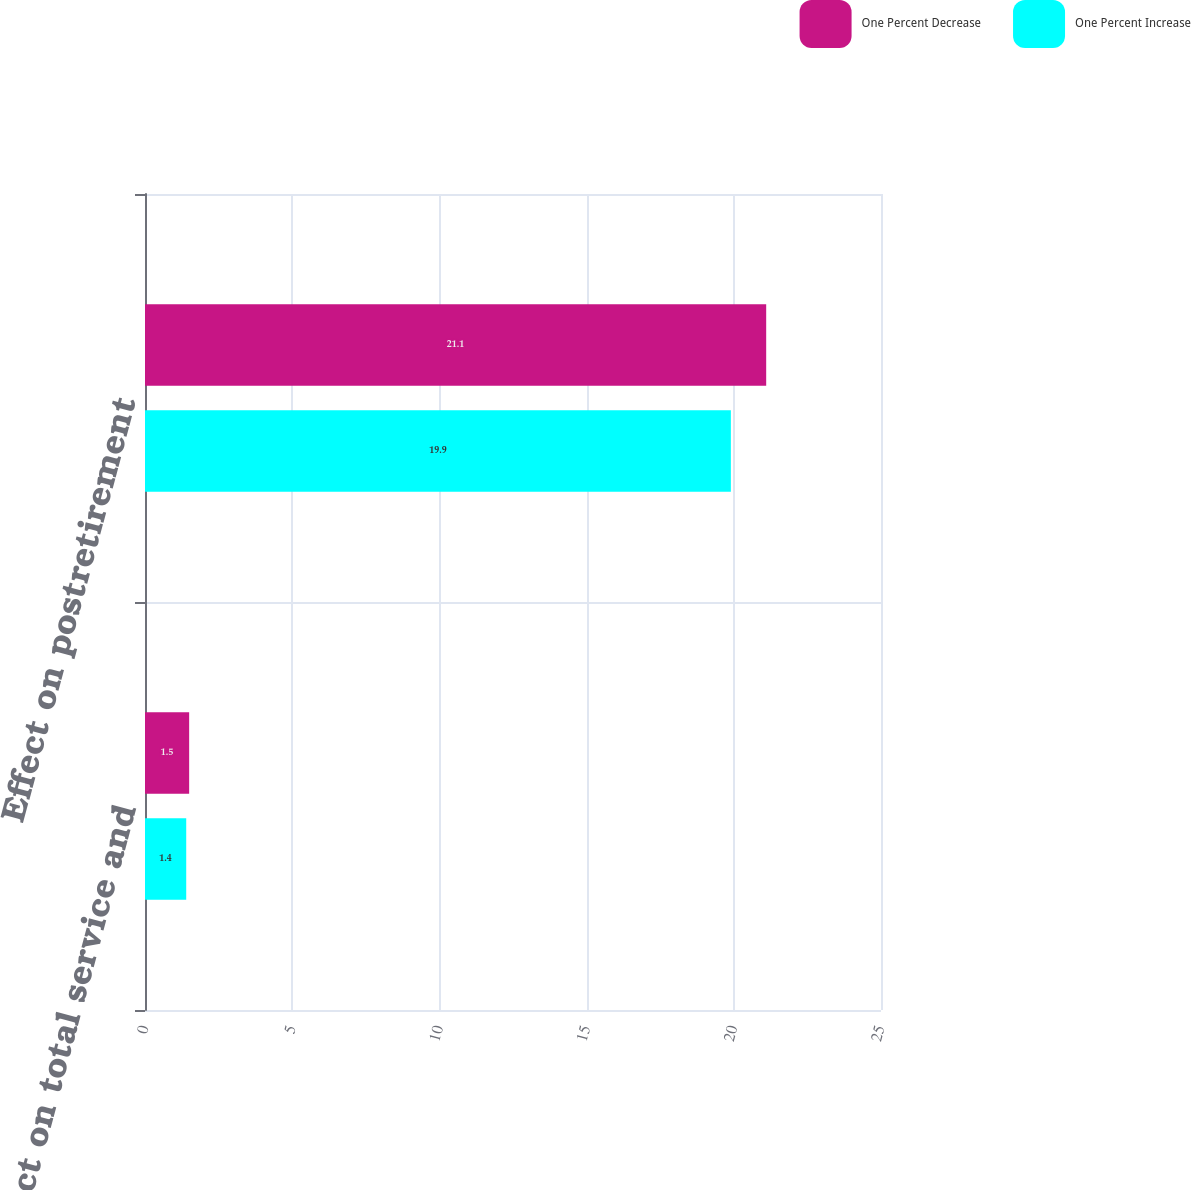<chart> <loc_0><loc_0><loc_500><loc_500><stacked_bar_chart><ecel><fcel>Effect on total service and<fcel>Effect on postretirement<nl><fcel>One Percent Decrease<fcel>1.5<fcel>21.1<nl><fcel>One Percent Increase<fcel>1.4<fcel>19.9<nl></chart> 